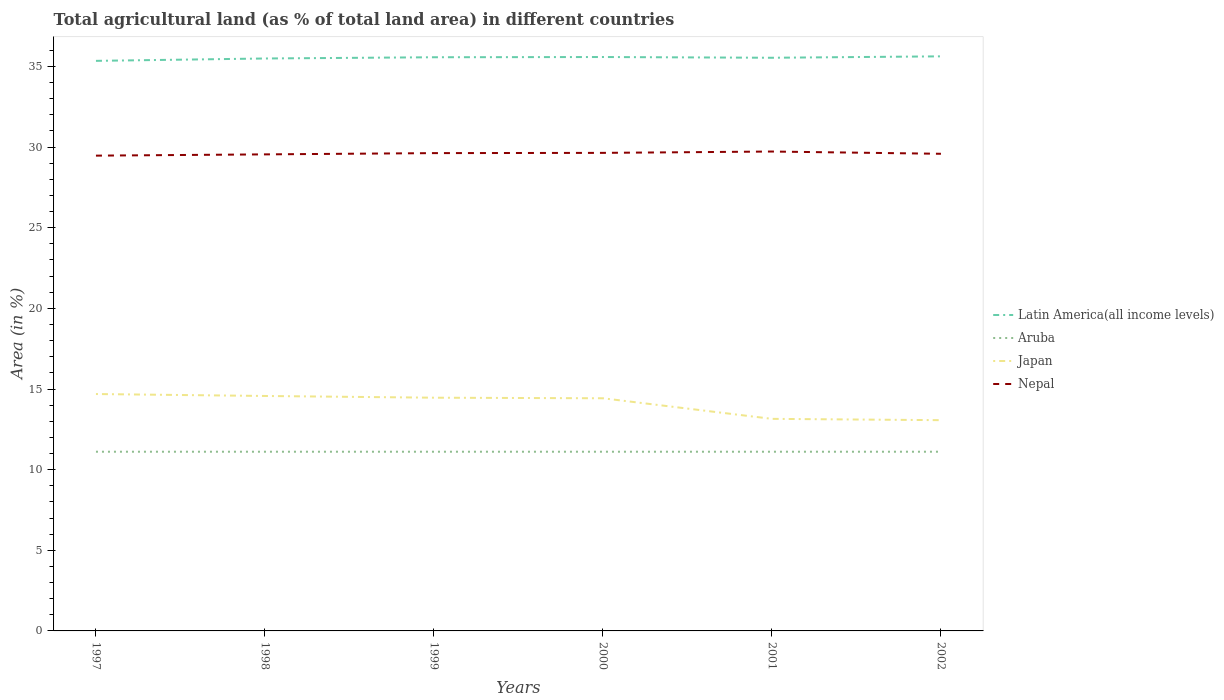How many different coloured lines are there?
Keep it short and to the point. 4. Across all years, what is the maximum percentage of agricultural land in Japan?
Provide a succinct answer. 13.07. In which year was the percentage of agricultural land in Japan maximum?
Your answer should be very brief. 2002. What is the total percentage of agricultural land in Japan in the graph?
Your answer should be very brief. 0.11. What is the difference between the highest and the second highest percentage of agricultural land in Aruba?
Offer a very short reply. 0. What is the difference between the highest and the lowest percentage of agricultural land in Aruba?
Your answer should be very brief. 0. Is the percentage of agricultural land in Nepal strictly greater than the percentage of agricultural land in Aruba over the years?
Make the answer very short. No. How many years are there in the graph?
Your response must be concise. 6. What is the difference between two consecutive major ticks on the Y-axis?
Ensure brevity in your answer.  5. Are the values on the major ticks of Y-axis written in scientific E-notation?
Offer a terse response. No. Does the graph contain any zero values?
Provide a succinct answer. No. How many legend labels are there?
Provide a succinct answer. 4. What is the title of the graph?
Your response must be concise. Total agricultural land (as % of total land area) in different countries. Does "Serbia" appear as one of the legend labels in the graph?
Offer a very short reply. No. What is the label or title of the Y-axis?
Your answer should be compact. Area (in %). What is the Area (in %) of Latin America(all income levels) in 1997?
Your answer should be compact. 35.35. What is the Area (in %) in Aruba in 1997?
Ensure brevity in your answer.  11.11. What is the Area (in %) of Japan in 1997?
Offer a terse response. 14.69. What is the Area (in %) in Nepal in 1997?
Your response must be concise. 29.47. What is the Area (in %) in Latin America(all income levels) in 1998?
Your response must be concise. 35.49. What is the Area (in %) in Aruba in 1998?
Your response must be concise. 11.11. What is the Area (in %) in Japan in 1998?
Your answer should be very brief. 14.57. What is the Area (in %) in Nepal in 1998?
Offer a terse response. 29.55. What is the Area (in %) in Latin America(all income levels) in 1999?
Give a very brief answer. 35.57. What is the Area (in %) of Aruba in 1999?
Keep it short and to the point. 11.11. What is the Area (in %) of Japan in 1999?
Offer a terse response. 14.46. What is the Area (in %) of Nepal in 1999?
Make the answer very short. 29.63. What is the Area (in %) in Latin America(all income levels) in 2000?
Keep it short and to the point. 35.58. What is the Area (in %) in Aruba in 2000?
Give a very brief answer. 11.11. What is the Area (in %) in Japan in 2000?
Your response must be concise. 14.43. What is the Area (in %) of Nepal in 2000?
Make the answer very short. 29.64. What is the Area (in %) of Latin America(all income levels) in 2001?
Make the answer very short. 35.54. What is the Area (in %) in Aruba in 2001?
Make the answer very short. 11.11. What is the Area (in %) in Japan in 2001?
Provide a succinct answer. 13.15. What is the Area (in %) of Nepal in 2001?
Give a very brief answer. 29.72. What is the Area (in %) in Latin America(all income levels) in 2002?
Give a very brief answer. 35.63. What is the Area (in %) of Aruba in 2002?
Make the answer very short. 11.11. What is the Area (in %) of Japan in 2002?
Ensure brevity in your answer.  13.07. What is the Area (in %) in Nepal in 2002?
Keep it short and to the point. 29.58. Across all years, what is the maximum Area (in %) of Latin America(all income levels)?
Offer a terse response. 35.63. Across all years, what is the maximum Area (in %) in Aruba?
Keep it short and to the point. 11.11. Across all years, what is the maximum Area (in %) in Japan?
Offer a terse response. 14.69. Across all years, what is the maximum Area (in %) in Nepal?
Give a very brief answer. 29.72. Across all years, what is the minimum Area (in %) of Latin America(all income levels)?
Provide a succinct answer. 35.35. Across all years, what is the minimum Area (in %) of Aruba?
Ensure brevity in your answer.  11.11. Across all years, what is the minimum Area (in %) of Japan?
Give a very brief answer. 13.07. Across all years, what is the minimum Area (in %) in Nepal?
Your response must be concise. 29.47. What is the total Area (in %) of Latin America(all income levels) in the graph?
Ensure brevity in your answer.  213.16. What is the total Area (in %) in Aruba in the graph?
Offer a terse response. 66.67. What is the total Area (in %) in Japan in the graph?
Keep it short and to the point. 84.36. What is the total Area (in %) of Nepal in the graph?
Keep it short and to the point. 177.6. What is the difference between the Area (in %) in Latin America(all income levels) in 1997 and that in 1998?
Keep it short and to the point. -0.15. What is the difference between the Area (in %) in Aruba in 1997 and that in 1998?
Keep it short and to the point. 0. What is the difference between the Area (in %) of Japan in 1997 and that in 1998?
Your response must be concise. 0.12. What is the difference between the Area (in %) in Nepal in 1997 and that in 1998?
Your answer should be very brief. -0.08. What is the difference between the Area (in %) of Latin America(all income levels) in 1997 and that in 1999?
Ensure brevity in your answer.  -0.22. What is the difference between the Area (in %) in Aruba in 1997 and that in 1999?
Provide a short and direct response. 0. What is the difference between the Area (in %) in Japan in 1997 and that in 1999?
Offer a very short reply. 0.23. What is the difference between the Area (in %) of Nepal in 1997 and that in 1999?
Provide a succinct answer. -0.16. What is the difference between the Area (in %) in Latin America(all income levels) in 1997 and that in 2000?
Offer a terse response. -0.24. What is the difference between the Area (in %) of Japan in 1997 and that in 2000?
Offer a very short reply. 0.26. What is the difference between the Area (in %) in Nepal in 1997 and that in 2000?
Ensure brevity in your answer.  -0.17. What is the difference between the Area (in %) of Latin America(all income levels) in 1997 and that in 2001?
Keep it short and to the point. -0.19. What is the difference between the Area (in %) of Aruba in 1997 and that in 2001?
Offer a very short reply. 0. What is the difference between the Area (in %) of Japan in 1997 and that in 2001?
Keep it short and to the point. 1.54. What is the difference between the Area (in %) in Nepal in 1997 and that in 2001?
Your answer should be very brief. -0.25. What is the difference between the Area (in %) in Latin America(all income levels) in 1997 and that in 2002?
Ensure brevity in your answer.  -0.28. What is the difference between the Area (in %) of Aruba in 1997 and that in 2002?
Your response must be concise. 0. What is the difference between the Area (in %) of Japan in 1997 and that in 2002?
Offer a very short reply. 1.62. What is the difference between the Area (in %) of Nepal in 1997 and that in 2002?
Provide a succinct answer. -0.12. What is the difference between the Area (in %) in Latin America(all income levels) in 1998 and that in 1999?
Provide a succinct answer. -0.08. What is the difference between the Area (in %) of Aruba in 1998 and that in 1999?
Your answer should be very brief. 0. What is the difference between the Area (in %) in Japan in 1998 and that in 1999?
Offer a terse response. 0.11. What is the difference between the Area (in %) of Nepal in 1998 and that in 1999?
Your response must be concise. -0.08. What is the difference between the Area (in %) in Latin America(all income levels) in 1998 and that in 2000?
Your answer should be compact. -0.09. What is the difference between the Area (in %) in Aruba in 1998 and that in 2000?
Offer a terse response. 0. What is the difference between the Area (in %) in Japan in 1998 and that in 2000?
Provide a short and direct response. 0.14. What is the difference between the Area (in %) of Nepal in 1998 and that in 2000?
Ensure brevity in your answer.  -0.09. What is the difference between the Area (in %) of Latin America(all income levels) in 1998 and that in 2001?
Your answer should be very brief. -0.04. What is the difference between the Area (in %) of Aruba in 1998 and that in 2001?
Provide a short and direct response. 0. What is the difference between the Area (in %) of Japan in 1998 and that in 2001?
Your answer should be compact. 1.42. What is the difference between the Area (in %) in Nepal in 1998 and that in 2001?
Ensure brevity in your answer.  -0.18. What is the difference between the Area (in %) in Latin America(all income levels) in 1998 and that in 2002?
Make the answer very short. -0.13. What is the difference between the Area (in %) of Aruba in 1998 and that in 2002?
Your answer should be compact. 0. What is the difference between the Area (in %) of Japan in 1998 and that in 2002?
Offer a very short reply. 1.5. What is the difference between the Area (in %) in Nepal in 1998 and that in 2002?
Offer a very short reply. -0.04. What is the difference between the Area (in %) in Latin America(all income levels) in 1999 and that in 2000?
Your answer should be very brief. -0.01. What is the difference between the Area (in %) in Aruba in 1999 and that in 2000?
Your answer should be compact. 0. What is the difference between the Area (in %) in Japan in 1999 and that in 2000?
Offer a very short reply. 0.04. What is the difference between the Area (in %) of Nepal in 1999 and that in 2000?
Offer a terse response. -0.01. What is the difference between the Area (in %) in Latin America(all income levels) in 1999 and that in 2001?
Keep it short and to the point. 0.03. What is the difference between the Area (in %) in Japan in 1999 and that in 2001?
Provide a succinct answer. 1.31. What is the difference between the Area (in %) of Nepal in 1999 and that in 2001?
Ensure brevity in your answer.  -0.1. What is the difference between the Area (in %) of Latin America(all income levels) in 1999 and that in 2002?
Offer a very short reply. -0.06. What is the difference between the Area (in %) of Japan in 1999 and that in 2002?
Provide a short and direct response. 1.39. What is the difference between the Area (in %) of Nepal in 1999 and that in 2002?
Offer a terse response. 0.04. What is the difference between the Area (in %) in Latin America(all income levels) in 2000 and that in 2001?
Give a very brief answer. 0.05. What is the difference between the Area (in %) in Japan in 2000 and that in 2001?
Your answer should be very brief. 1.28. What is the difference between the Area (in %) of Nepal in 2000 and that in 2001?
Ensure brevity in your answer.  -0.08. What is the difference between the Area (in %) of Latin America(all income levels) in 2000 and that in 2002?
Your answer should be very brief. -0.04. What is the difference between the Area (in %) of Aruba in 2000 and that in 2002?
Offer a very short reply. 0. What is the difference between the Area (in %) of Japan in 2000 and that in 2002?
Your response must be concise. 1.36. What is the difference between the Area (in %) of Nepal in 2000 and that in 2002?
Your answer should be compact. 0.06. What is the difference between the Area (in %) in Latin America(all income levels) in 2001 and that in 2002?
Your answer should be compact. -0.09. What is the difference between the Area (in %) of Japan in 2001 and that in 2002?
Your answer should be compact. 0.08. What is the difference between the Area (in %) of Nepal in 2001 and that in 2002?
Keep it short and to the point. 0.14. What is the difference between the Area (in %) of Latin America(all income levels) in 1997 and the Area (in %) of Aruba in 1998?
Give a very brief answer. 24.24. What is the difference between the Area (in %) of Latin America(all income levels) in 1997 and the Area (in %) of Japan in 1998?
Provide a succinct answer. 20.78. What is the difference between the Area (in %) of Latin America(all income levels) in 1997 and the Area (in %) of Nepal in 1998?
Give a very brief answer. 5.8. What is the difference between the Area (in %) in Aruba in 1997 and the Area (in %) in Japan in 1998?
Your answer should be very brief. -3.46. What is the difference between the Area (in %) of Aruba in 1997 and the Area (in %) of Nepal in 1998?
Offer a very short reply. -18.44. What is the difference between the Area (in %) of Japan in 1997 and the Area (in %) of Nepal in 1998?
Your answer should be compact. -14.86. What is the difference between the Area (in %) of Latin America(all income levels) in 1997 and the Area (in %) of Aruba in 1999?
Offer a very short reply. 24.24. What is the difference between the Area (in %) in Latin America(all income levels) in 1997 and the Area (in %) in Japan in 1999?
Offer a very short reply. 20.89. What is the difference between the Area (in %) of Latin America(all income levels) in 1997 and the Area (in %) of Nepal in 1999?
Provide a succinct answer. 5.72. What is the difference between the Area (in %) of Aruba in 1997 and the Area (in %) of Japan in 1999?
Ensure brevity in your answer.  -3.35. What is the difference between the Area (in %) of Aruba in 1997 and the Area (in %) of Nepal in 1999?
Provide a short and direct response. -18.52. What is the difference between the Area (in %) in Japan in 1997 and the Area (in %) in Nepal in 1999?
Make the answer very short. -14.94. What is the difference between the Area (in %) of Latin America(all income levels) in 1997 and the Area (in %) of Aruba in 2000?
Offer a very short reply. 24.24. What is the difference between the Area (in %) in Latin America(all income levels) in 1997 and the Area (in %) in Japan in 2000?
Provide a short and direct response. 20.92. What is the difference between the Area (in %) of Latin America(all income levels) in 1997 and the Area (in %) of Nepal in 2000?
Give a very brief answer. 5.71. What is the difference between the Area (in %) of Aruba in 1997 and the Area (in %) of Japan in 2000?
Keep it short and to the point. -3.31. What is the difference between the Area (in %) in Aruba in 1997 and the Area (in %) in Nepal in 2000?
Make the answer very short. -18.53. What is the difference between the Area (in %) in Japan in 1997 and the Area (in %) in Nepal in 2000?
Provide a succinct answer. -14.95. What is the difference between the Area (in %) in Latin America(all income levels) in 1997 and the Area (in %) in Aruba in 2001?
Provide a short and direct response. 24.24. What is the difference between the Area (in %) of Latin America(all income levels) in 1997 and the Area (in %) of Japan in 2001?
Your answer should be very brief. 22.2. What is the difference between the Area (in %) of Latin America(all income levels) in 1997 and the Area (in %) of Nepal in 2001?
Provide a succinct answer. 5.62. What is the difference between the Area (in %) of Aruba in 1997 and the Area (in %) of Japan in 2001?
Provide a succinct answer. -2.04. What is the difference between the Area (in %) of Aruba in 1997 and the Area (in %) of Nepal in 2001?
Provide a succinct answer. -18.61. What is the difference between the Area (in %) of Japan in 1997 and the Area (in %) of Nepal in 2001?
Make the answer very short. -15.04. What is the difference between the Area (in %) in Latin America(all income levels) in 1997 and the Area (in %) in Aruba in 2002?
Provide a succinct answer. 24.24. What is the difference between the Area (in %) in Latin America(all income levels) in 1997 and the Area (in %) in Japan in 2002?
Your response must be concise. 22.28. What is the difference between the Area (in %) in Latin America(all income levels) in 1997 and the Area (in %) in Nepal in 2002?
Keep it short and to the point. 5.76. What is the difference between the Area (in %) in Aruba in 1997 and the Area (in %) in Japan in 2002?
Your answer should be very brief. -1.96. What is the difference between the Area (in %) of Aruba in 1997 and the Area (in %) of Nepal in 2002?
Make the answer very short. -18.47. What is the difference between the Area (in %) in Japan in 1997 and the Area (in %) in Nepal in 2002?
Make the answer very short. -14.9. What is the difference between the Area (in %) of Latin America(all income levels) in 1998 and the Area (in %) of Aruba in 1999?
Give a very brief answer. 24.38. What is the difference between the Area (in %) in Latin America(all income levels) in 1998 and the Area (in %) in Japan in 1999?
Keep it short and to the point. 21.03. What is the difference between the Area (in %) of Latin America(all income levels) in 1998 and the Area (in %) of Nepal in 1999?
Your answer should be compact. 5.87. What is the difference between the Area (in %) of Aruba in 1998 and the Area (in %) of Japan in 1999?
Your answer should be compact. -3.35. What is the difference between the Area (in %) of Aruba in 1998 and the Area (in %) of Nepal in 1999?
Keep it short and to the point. -18.52. What is the difference between the Area (in %) in Japan in 1998 and the Area (in %) in Nepal in 1999?
Give a very brief answer. -15.06. What is the difference between the Area (in %) in Latin America(all income levels) in 1998 and the Area (in %) in Aruba in 2000?
Offer a very short reply. 24.38. What is the difference between the Area (in %) of Latin America(all income levels) in 1998 and the Area (in %) of Japan in 2000?
Your answer should be compact. 21.07. What is the difference between the Area (in %) of Latin America(all income levels) in 1998 and the Area (in %) of Nepal in 2000?
Ensure brevity in your answer.  5.85. What is the difference between the Area (in %) of Aruba in 1998 and the Area (in %) of Japan in 2000?
Offer a very short reply. -3.31. What is the difference between the Area (in %) of Aruba in 1998 and the Area (in %) of Nepal in 2000?
Ensure brevity in your answer.  -18.53. What is the difference between the Area (in %) in Japan in 1998 and the Area (in %) in Nepal in 2000?
Your answer should be very brief. -15.07. What is the difference between the Area (in %) of Latin America(all income levels) in 1998 and the Area (in %) of Aruba in 2001?
Your response must be concise. 24.38. What is the difference between the Area (in %) in Latin America(all income levels) in 1998 and the Area (in %) in Japan in 2001?
Your answer should be very brief. 22.34. What is the difference between the Area (in %) of Latin America(all income levels) in 1998 and the Area (in %) of Nepal in 2001?
Your answer should be very brief. 5.77. What is the difference between the Area (in %) of Aruba in 1998 and the Area (in %) of Japan in 2001?
Offer a very short reply. -2.04. What is the difference between the Area (in %) of Aruba in 1998 and the Area (in %) of Nepal in 2001?
Offer a very short reply. -18.61. What is the difference between the Area (in %) in Japan in 1998 and the Area (in %) in Nepal in 2001?
Offer a very short reply. -15.16. What is the difference between the Area (in %) of Latin America(all income levels) in 1998 and the Area (in %) of Aruba in 2002?
Offer a very short reply. 24.38. What is the difference between the Area (in %) of Latin America(all income levels) in 1998 and the Area (in %) of Japan in 2002?
Keep it short and to the point. 22.43. What is the difference between the Area (in %) of Latin America(all income levels) in 1998 and the Area (in %) of Nepal in 2002?
Ensure brevity in your answer.  5.91. What is the difference between the Area (in %) of Aruba in 1998 and the Area (in %) of Japan in 2002?
Keep it short and to the point. -1.96. What is the difference between the Area (in %) in Aruba in 1998 and the Area (in %) in Nepal in 2002?
Offer a very short reply. -18.47. What is the difference between the Area (in %) in Japan in 1998 and the Area (in %) in Nepal in 2002?
Provide a succinct answer. -15.02. What is the difference between the Area (in %) of Latin America(all income levels) in 1999 and the Area (in %) of Aruba in 2000?
Ensure brevity in your answer.  24.46. What is the difference between the Area (in %) of Latin America(all income levels) in 1999 and the Area (in %) of Japan in 2000?
Give a very brief answer. 21.15. What is the difference between the Area (in %) in Latin America(all income levels) in 1999 and the Area (in %) in Nepal in 2000?
Keep it short and to the point. 5.93. What is the difference between the Area (in %) in Aruba in 1999 and the Area (in %) in Japan in 2000?
Provide a short and direct response. -3.31. What is the difference between the Area (in %) of Aruba in 1999 and the Area (in %) of Nepal in 2000?
Make the answer very short. -18.53. What is the difference between the Area (in %) in Japan in 1999 and the Area (in %) in Nepal in 2000?
Ensure brevity in your answer.  -15.18. What is the difference between the Area (in %) in Latin America(all income levels) in 1999 and the Area (in %) in Aruba in 2001?
Provide a short and direct response. 24.46. What is the difference between the Area (in %) of Latin America(all income levels) in 1999 and the Area (in %) of Japan in 2001?
Offer a terse response. 22.42. What is the difference between the Area (in %) in Latin America(all income levels) in 1999 and the Area (in %) in Nepal in 2001?
Keep it short and to the point. 5.85. What is the difference between the Area (in %) of Aruba in 1999 and the Area (in %) of Japan in 2001?
Your answer should be very brief. -2.04. What is the difference between the Area (in %) of Aruba in 1999 and the Area (in %) of Nepal in 2001?
Provide a short and direct response. -18.61. What is the difference between the Area (in %) of Japan in 1999 and the Area (in %) of Nepal in 2001?
Your response must be concise. -15.26. What is the difference between the Area (in %) of Latin America(all income levels) in 1999 and the Area (in %) of Aruba in 2002?
Your answer should be compact. 24.46. What is the difference between the Area (in %) of Latin America(all income levels) in 1999 and the Area (in %) of Japan in 2002?
Make the answer very short. 22.5. What is the difference between the Area (in %) of Latin America(all income levels) in 1999 and the Area (in %) of Nepal in 2002?
Ensure brevity in your answer.  5.99. What is the difference between the Area (in %) of Aruba in 1999 and the Area (in %) of Japan in 2002?
Your response must be concise. -1.96. What is the difference between the Area (in %) of Aruba in 1999 and the Area (in %) of Nepal in 2002?
Offer a terse response. -18.47. What is the difference between the Area (in %) in Japan in 1999 and the Area (in %) in Nepal in 2002?
Provide a short and direct response. -15.12. What is the difference between the Area (in %) in Latin America(all income levels) in 2000 and the Area (in %) in Aruba in 2001?
Make the answer very short. 24.47. What is the difference between the Area (in %) of Latin America(all income levels) in 2000 and the Area (in %) of Japan in 2001?
Ensure brevity in your answer.  22.44. What is the difference between the Area (in %) of Latin America(all income levels) in 2000 and the Area (in %) of Nepal in 2001?
Ensure brevity in your answer.  5.86. What is the difference between the Area (in %) of Aruba in 2000 and the Area (in %) of Japan in 2001?
Keep it short and to the point. -2.04. What is the difference between the Area (in %) of Aruba in 2000 and the Area (in %) of Nepal in 2001?
Make the answer very short. -18.61. What is the difference between the Area (in %) of Japan in 2000 and the Area (in %) of Nepal in 2001?
Give a very brief answer. -15.3. What is the difference between the Area (in %) of Latin America(all income levels) in 2000 and the Area (in %) of Aruba in 2002?
Ensure brevity in your answer.  24.47. What is the difference between the Area (in %) of Latin America(all income levels) in 2000 and the Area (in %) of Japan in 2002?
Make the answer very short. 22.52. What is the difference between the Area (in %) in Latin America(all income levels) in 2000 and the Area (in %) in Nepal in 2002?
Make the answer very short. 6. What is the difference between the Area (in %) in Aruba in 2000 and the Area (in %) in Japan in 2002?
Offer a terse response. -1.96. What is the difference between the Area (in %) of Aruba in 2000 and the Area (in %) of Nepal in 2002?
Offer a terse response. -18.47. What is the difference between the Area (in %) in Japan in 2000 and the Area (in %) in Nepal in 2002?
Provide a succinct answer. -15.16. What is the difference between the Area (in %) in Latin America(all income levels) in 2001 and the Area (in %) in Aruba in 2002?
Ensure brevity in your answer.  24.43. What is the difference between the Area (in %) of Latin America(all income levels) in 2001 and the Area (in %) of Japan in 2002?
Ensure brevity in your answer.  22.47. What is the difference between the Area (in %) in Latin America(all income levels) in 2001 and the Area (in %) in Nepal in 2002?
Offer a terse response. 5.95. What is the difference between the Area (in %) in Aruba in 2001 and the Area (in %) in Japan in 2002?
Your response must be concise. -1.96. What is the difference between the Area (in %) in Aruba in 2001 and the Area (in %) in Nepal in 2002?
Your response must be concise. -18.47. What is the difference between the Area (in %) in Japan in 2001 and the Area (in %) in Nepal in 2002?
Your answer should be compact. -16.44. What is the average Area (in %) of Latin America(all income levels) per year?
Ensure brevity in your answer.  35.53. What is the average Area (in %) in Aruba per year?
Ensure brevity in your answer.  11.11. What is the average Area (in %) in Japan per year?
Offer a terse response. 14.06. What is the average Area (in %) of Nepal per year?
Your response must be concise. 29.6. In the year 1997, what is the difference between the Area (in %) of Latin America(all income levels) and Area (in %) of Aruba?
Offer a terse response. 24.24. In the year 1997, what is the difference between the Area (in %) in Latin America(all income levels) and Area (in %) in Japan?
Offer a very short reply. 20.66. In the year 1997, what is the difference between the Area (in %) of Latin America(all income levels) and Area (in %) of Nepal?
Your answer should be very brief. 5.88. In the year 1997, what is the difference between the Area (in %) in Aruba and Area (in %) in Japan?
Your answer should be very brief. -3.58. In the year 1997, what is the difference between the Area (in %) of Aruba and Area (in %) of Nepal?
Your response must be concise. -18.36. In the year 1997, what is the difference between the Area (in %) in Japan and Area (in %) in Nepal?
Make the answer very short. -14.78. In the year 1998, what is the difference between the Area (in %) of Latin America(all income levels) and Area (in %) of Aruba?
Offer a very short reply. 24.38. In the year 1998, what is the difference between the Area (in %) of Latin America(all income levels) and Area (in %) of Japan?
Provide a succinct answer. 20.93. In the year 1998, what is the difference between the Area (in %) of Latin America(all income levels) and Area (in %) of Nepal?
Make the answer very short. 5.95. In the year 1998, what is the difference between the Area (in %) of Aruba and Area (in %) of Japan?
Offer a very short reply. -3.46. In the year 1998, what is the difference between the Area (in %) in Aruba and Area (in %) in Nepal?
Your answer should be compact. -18.44. In the year 1998, what is the difference between the Area (in %) in Japan and Area (in %) in Nepal?
Give a very brief answer. -14.98. In the year 1999, what is the difference between the Area (in %) in Latin America(all income levels) and Area (in %) in Aruba?
Offer a very short reply. 24.46. In the year 1999, what is the difference between the Area (in %) in Latin America(all income levels) and Area (in %) in Japan?
Provide a short and direct response. 21.11. In the year 1999, what is the difference between the Area (in %) in Latin America(all income levels) and Area (in %) in Nepal?
Provide a succinct answer. 5.94. In the year 1999, what is the difference between the Area (in %) in Aruba and Area (in %) in Japan?
Your response must be concise. -3.35. In the year 1999, what is the difference between the Area (in %) of Aruba and Area (in %) of Nepal?
Offer a terse response. -18.52. In the year 1999, what is the difference between the Area (in %) in Japan and Area (in %) in Nepal?
Give a very brief answer. -15.17. In the year 2000, what is the difference between the Area (in %) of Latin America(all income levels) and Area (in %) of Aruba?
Keep it short and to the point. 24.47. In the year 2000, what is the difference between the Area (in %) in Latin America(all income levels) and Area (in %) in Japan?
Your response must be concise. 21.16. In the year 2000, what is the difference between the Area (in %) of Latin America(all income levels) and Area (in %) of Nepal?
Provide a short and direct response. 5.94. In the year 2000, what is the difference between the Area (in %) in Aruba and Area (in %) in Japan?
Offer a very short reply. -3.31. In the year 2000, what is the difference between the Area (in %) of Aruba and Area (in %) of Nepal?
Offer a very short reply. -18.53. In the year 2000, what is the difference between the Area (in %) of Japan and Area (in %) of Nepal?
Your answer should be very brief. -15.22. In the year 2001, what is the difference between the Area (in %) of Latin America(all income levels) and Area (in %) of Aruba?
Your answer should be compact. 24.43. In the year 2001, what is the difference between the Area (in %) of Latin America(all income levels) and Area (in %) of Japan?
Ensure brevity in your answer.  22.39. In the year 2001, what is the difference between the Area (in %) in Latin America(all income levels) and Area (in %) in Nepal?
Offer a very short reply. 5.81. In the year 2001, what is the difference between the Area (in %) of Aruba and Area (in %) of Japan?
Your response must be concise. -2.04. In the year 2001, what is the difference between the Area (in %) in Aruba and Area (in %) in Nepal?
Make the answer very short. -18.61. In the year 2001, what is the difference between the Area (in %) of Japan and Area (in %) of Nepal?
Your answer should be compact. -16.57. In the year 2002, what is the difference between the Area (in %) in Latin America(all income levels) and Area (in %) in Aruba?
Your answer should be compact. 24.52. In the year 2002, what is the difference between the Area (in %) in Latin America(all income levels) and Area (in %) in Japan?
Your answer should be very brief. 22.56. In the year 2002, what is the difference between the Area (in %) of Latin America(all income levels) and Area (in %) of Nepal?
Ensure brevity in your answer.  6.04. In the year 2002, what is the difference between the Area (in %) in Aruba and Area (in %) in Japan?
Make the answer very short. -1.96. In the year 2002, what is the difference between the Area (in %) of Aruba and Area (in %) of Nepal?
Ensure brevity in your answer.  -18.47. In the year 2002, what is the difference between the Area (in %) in Japan and Area (in %) in Nepal?
Offer a very short reply. -16.52. What is the ratio of the Area (in %) in Latin America(all income levels) in 1997 to that in 1998?
Your response must be concise. 1. What is the ratio of the Area (in %) in Aruba in 1997 to that in 1998?
Keep it short and to the point. 1. What is the ratio of the Area (in %) in Japan in 1997 to that in 1998?
Give a very brief answer. 1.01. What is the ratio of the Area (in %) in Nepal in 1997 to that in 1998?
Offer a very short reply. 1. What is the ratio of the Area (in %) in Latin America(all income levels) in 1997 to that in 1999?
Offer a terse response. 0.99. What is the ratio of the Area (in %) of Japan in 1997 to that in 1999?
Your answer should be compact. 1.02. What is the ratio of the Area (in %) in Nepal in 1997 to that in 1999?
Give a very brief answer. 0.99. What is the ratio of the Area (in %) of Japan in 1997 to that in 2000?
Provide a succinct answer. 1.02. What is the ratio of the Area (in %) in Latin America(all income levels) in 1997 to that in 2001?
Make the answer very short. 0.99. What is the ratio of the Area (in %) of Japan in 1997 to that in 2001?
Make the answer very short. 1.12. What is the ratio of the Area (in %) of Nepal in 1997 to that in 2001?
Ensure brevity in your answer.  0.99. What is the ratio of the Area (in %) of Latin America(all income levels) in 1997 to that in 2002?
Ensure brevity in your answer.  0.99. What is the ratio of the Area (in %) of Aruba in 1997 to that in 2002?
Your answer should be very brief. 1. What is the ratio of the Area (in %) of Japan in 1997 to that in 2002?
Ensure brevity in your answer.  1.12. What is the ratio of the Area (in %) in Latin America(all income levels) in 1998 to that in 1999?
Give a very brief answer. 1. What is the ratio of the Area (in %) of Aruba in 1998 to that in 1999?
Your answer should be compact. 1. What is the ratio of the Area (in %) of Japan in 1998 to that in 1999?
Offer a very short reply. 1.01. What is the ratio of the Area (in %) of Nepal in 1998 to that in 1999?
Your answer should be compact. 1. What is the ratio of the Area (in %) in Latin America(all income levels) in 1998 to that in 2000?
Make the answer very short. 1. What is the ratio of the Area (in %) in Japan in 1998 to that in 2000?
Offer a terse response. 1.01. What is the ratio of the Area (in %) of Latin America(all income levels) in 1998 to that in 2001?
Provide a succinct answer. 1. What is the ratio of the Area (in %) of Aruba in 1998 to that in 2001?
Ensure brevity in your answer.  1. What is the ratio of the Area (in %) of Japan in 1998 to that in 2001?
Offer a terse response. 1.11. What is the ratio of the Area (in %) of Nepal in 1998 to that in 2001?
Your response must be concise. 0.99. What is the ratio of the Area (in %) in Latin America(all income levels) in 1998 to that in 2002?
Keep it short and to the point. 1. What is the ratio of the Area (in %) in Japan in 1998 to that in 2002?
Your answer should be compact. 1.11. What is the ratio of the Area (in %) of Latin America(all income levels) in 1999 to that in 2000?
Offer a terse response. 1. What is the ratio of the Area (in %) of Latin America(all income levels) in 1999 to that in 2001?
Give a very brief answer. 1. What is the ratio of the Area (in %) of Japan in 1999 to that in 2001?
Offer a very short reply. 1.1. What is the ratio of the Area (in %) of Latin America(all income levels) in 1999 to that in 2002?
Give a very brief answer. 1. What is the ratio of the Area (in %) in Japan in 1999 to that in 2002?
Ensure brevity in your answer.  1.11. What is the ratio of the Area (in %) in Japan in 2000 to that in 2001?
Ensure brevity in your answer.  1.1. What is the ratio of the Area (in %) of Japan in 2000 to that in 2002?
Your answer should be compact. 1.1. What is the ratio of the Area (in %) of Latin America(all income levels) in 2001 to that in 2002?
Make the answer very short. 1. What is the ratio of the Area (in %) of Aruba in 2001 to that in 2002?
Make the answer very short. 1. What is the ratio of the Area (in %) in Japan in 2001 to that in 2002?
Your answer should be compact. 1.01. What is the ratio of the Area (in %) of Nepal in 2001 to that in 2002?
Provide a short and direct response. 1. What is the difference between the highest and the second highest Area (in %) in Latin America(all income levels)?
Make the answer very short. 0.04. What is the difference between the highest and the second highest Area (in %) in Aruba?
Give a very brief answer. 0. What is the difference between the highest and the second highest Area (in %) in Japan?
Ensure brevity in your answer.  0.12. What is the difference between the highest and the second highest Area (in %) in Nepal?
Provide a short and direct response. 0.08. What is the difference between the highest and the lowest Area (in %) of Latin America(all income levels)?
Give a very brief answer. 0.28. What is the difference between the highest and the lowest Area (in %) in Aruba?
Ensure brevity in your answer.  0. What is the difference between the highest and the lowest Area (in %) of Japan?
Ensure brevity in your answer.  1.62. What is the difference between the highest and the lowest Area (in %) of Nepal?
Provide a short and direct response. 0.25. 